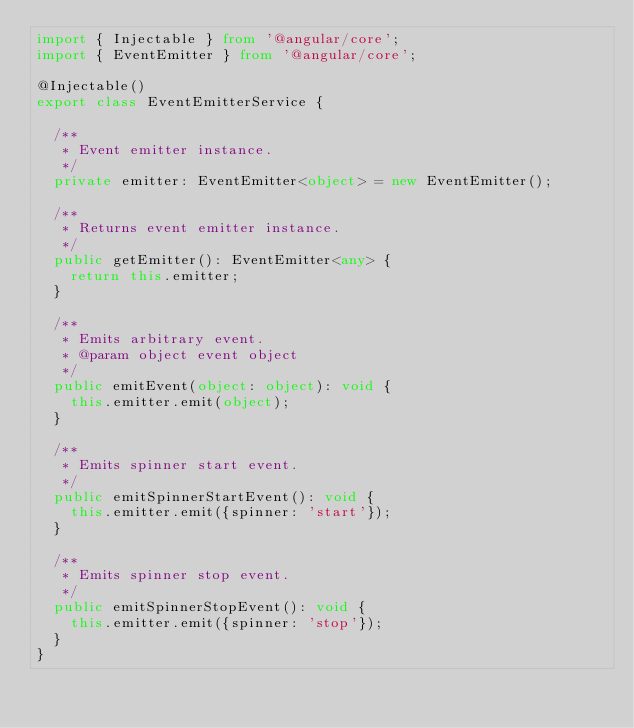Convert code to text. <code><loc_0><loc_0><loc_500><loc_500><_TypeScript_>import { Injectable } from '@angular/core';
import { EventEmitter } from '@angular/core';

@Injectable()
export class EventEmitterService {

	/**
	 * Event emitter instance.
	 */
	private emitter: EventEmitter<object> = new EventEmitter();

	/**
	 * Returns event emitter instance.
	 */
	public getEmitter(): EventEmitter<any> {
		return this.emitter;
	}

	/**
	 * Emits arbitrary event.
	 * @param object event object
	 */
	public emitEvent(object: object): void {
		this.emitter.emit(object);
	}

	/**
	 * Emits spinner start event.
	 */
	public emitSpinnerStartEvent(): void {
		this.emitter.emit({spinner: 'start'});
	}

	/**
	 * Emits spinner stop event.
	 */
	public emitSpinnerStopEvent(): void {
		this.emitter.emit({spinner: 'stop'});
	}
}
</code> 